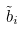<formula> <loc_0><loc_0><loc_500><loc_500>\tilde { b } _ { i }</formula> 